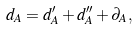Convert formula to latex. <formula><loc_0><loc_0><loc_500><loc_500>d _ { A } = d ^ { \prime } _ { A } + d ^ { \prime \prime } _ { A } + \partial _ { A } ,</formula> 